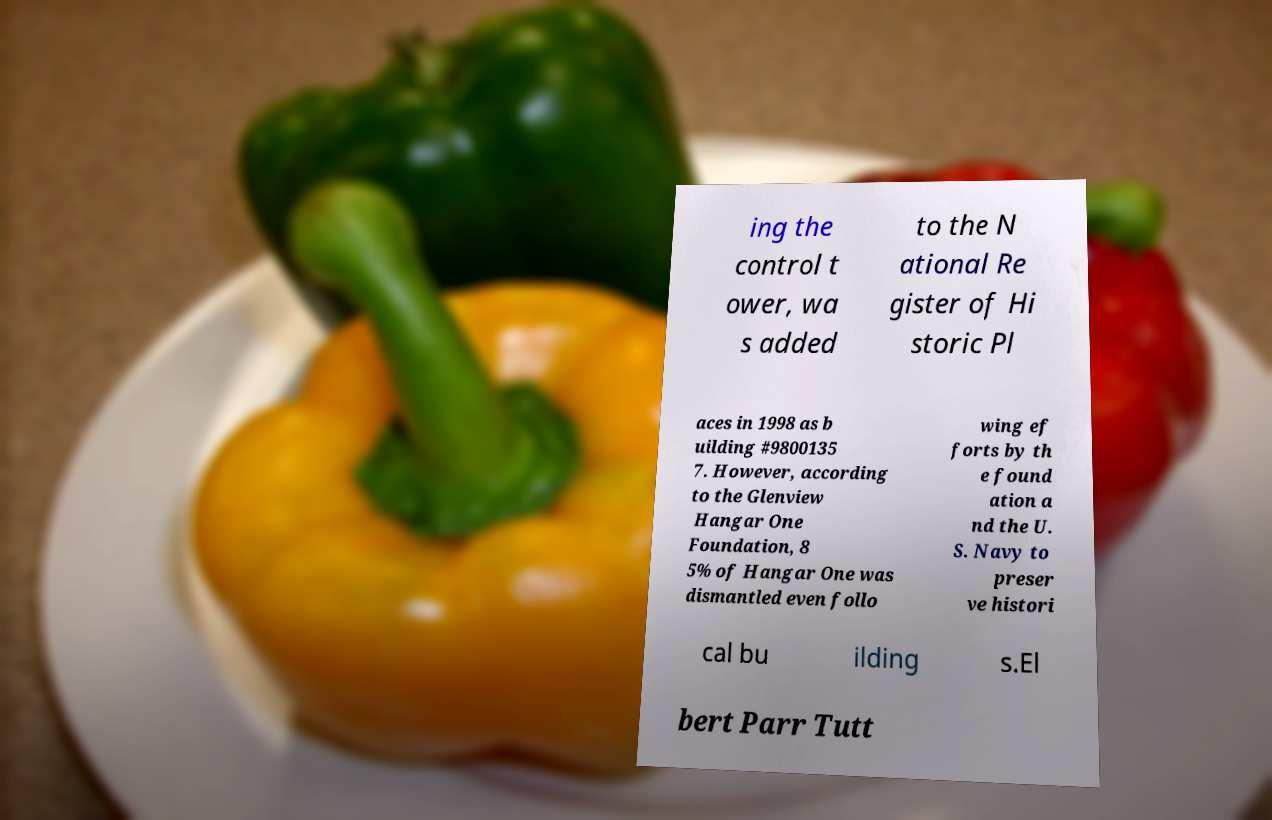Can you accurately transcribe the text from the provided image for me? ing the control t ower, wa s added to the N ational Re gister of Hi storic Pl aces in 1998 as b uilding #9800135 7. However, according to the Glenview Hangar One Foundation, 8 5% of Hangar One was dismantled even follo wing ef forts by th e found ation a nd the U. S. Navy to preser ve histori cal bu ilding s.El bert Parr Tutt 